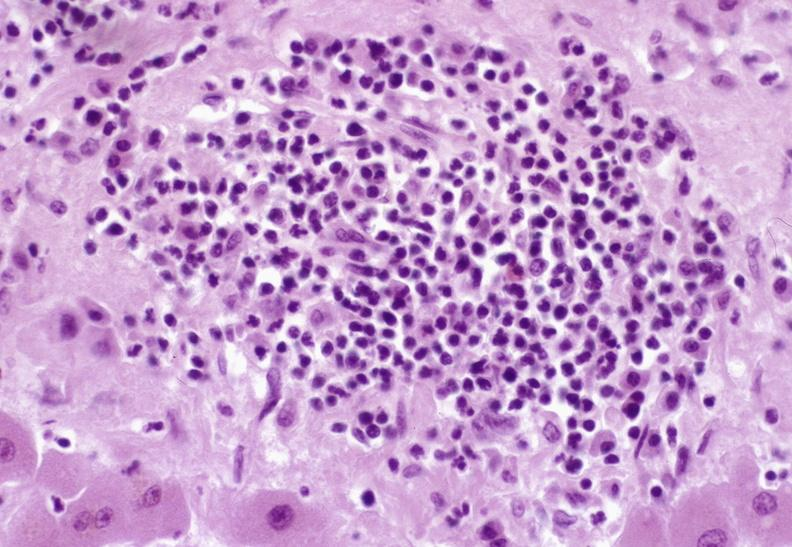what does this image show?
Answer the question using a single word or phrase. Severe acute rejection 